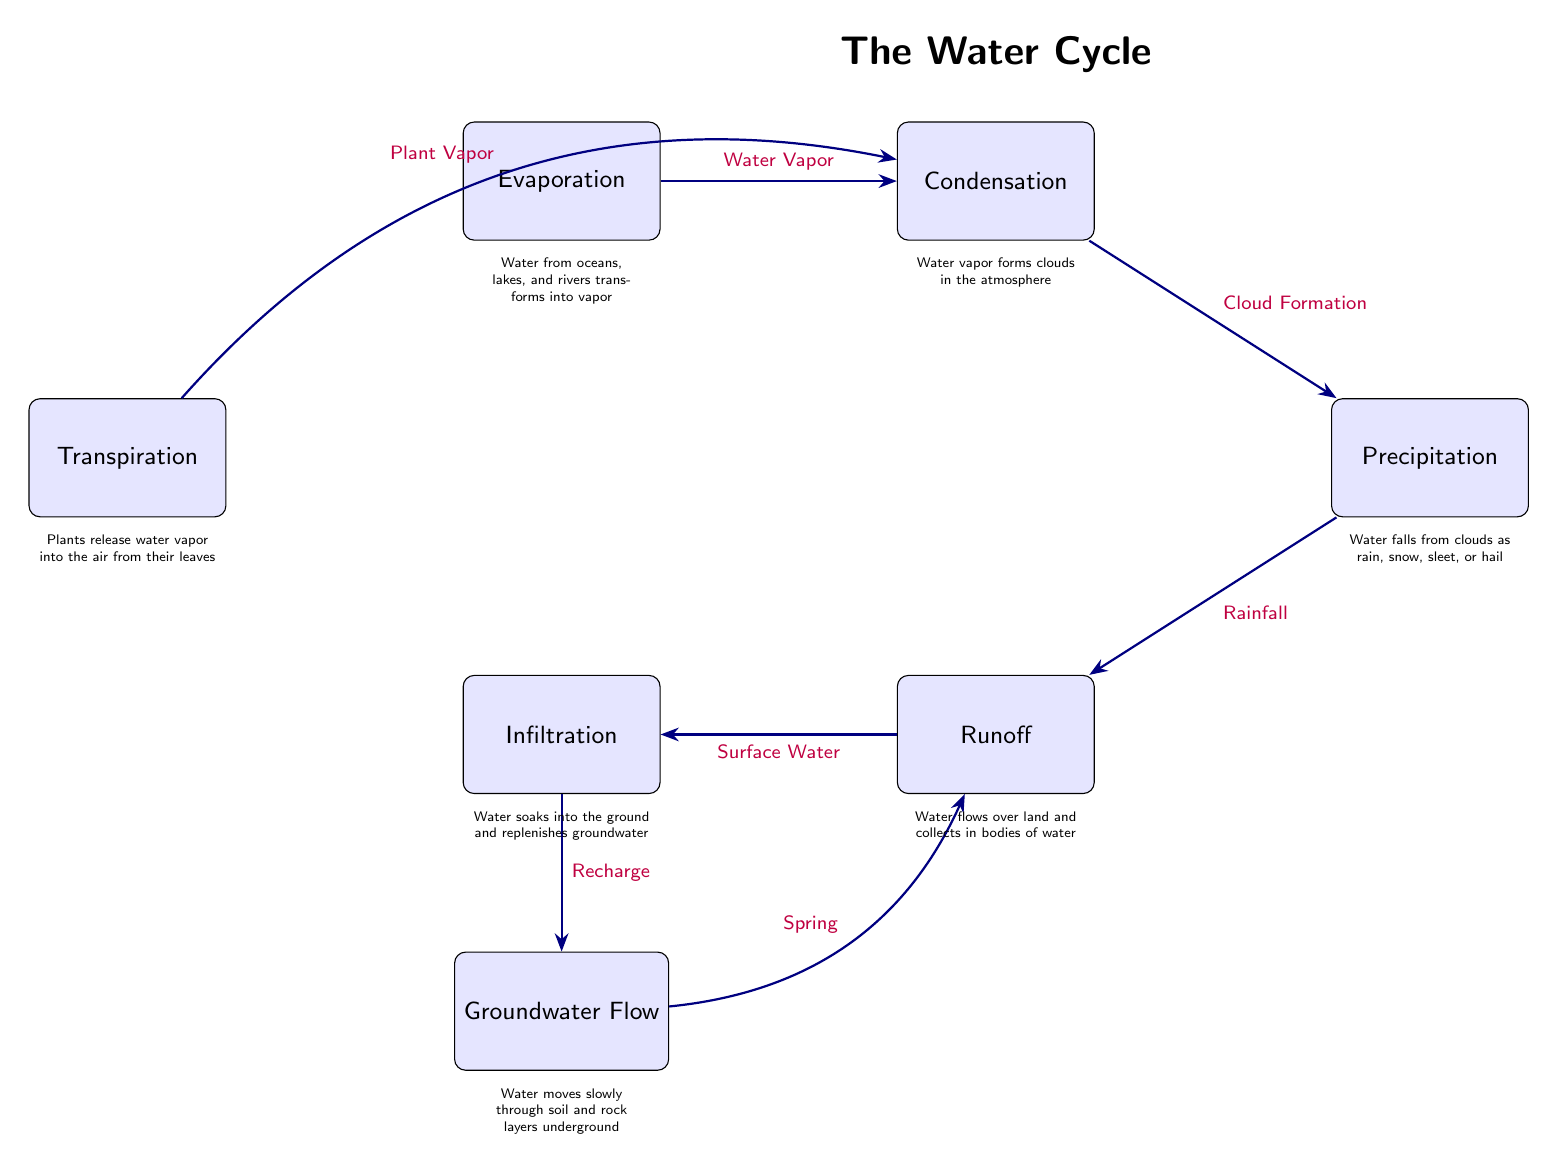What are the key processes shown in the diagram? The diagram lists several key processes: Evaporation, Condensation, Precipitation, Runoff, Infiltration, Transpiration, and Groundwater Flow. These processes illustrate different stages of the water cycle.
Answer: Evaporation, Condensation, Precipitation, Runoff, Infiltration, Transpiration, Groundwater Flow How many transition arrows are in the diagram? By counting the arrows connecting the processes, we identify six transition arrows: Water Vapor, Cloud Formation, Rainfall, Surface Water, Recharge, and Plant Vapor, and Spring. Thus, there are six arrows.
Answer: 6 What type of water movement is represented by 'Infiltration'? 'Infiltration' describes the process of water soaking into the ground, replenishing groundwater. This defines the movement of water through the soil.
Answer: Soaking into the ground Which process follows 'Condensation'? The transition from 'Condensation' leads directly to 'Precipitation', indicating that condensation is followed by the release of water as precipitation.
Answer: Precipitation What does 'Transpiration' release? 'Transpiration' is the process where plants release water vapor into the air, which is a significant component of the water cycle.
Answer: Water vapor What connects 'Groundwater Flow' to 'Runoff'? The connection between 'Groundwater Flow' and 'Runoff' is established through the transition labeled 'Spring', indicating that groundwater can surface and become runoff.
Answer: Spring How does 'Evaporation' contribute to 'Condensation'? 'Evaporation' transforms water from oceans and lakes into vapor, which is then transported and cooled in the atmosphere, leading to 'Condensation' as vapor forms clouds.
Answer: Water Vapor What role does 'Precipitation' play in the water cycle? 'Precipitation' is a critical process where water falls from clouds as rain, snow, sleet, or hail, returning water to the Earth's surface to replenish bodies of water.
Answer: Water falls from clouds 